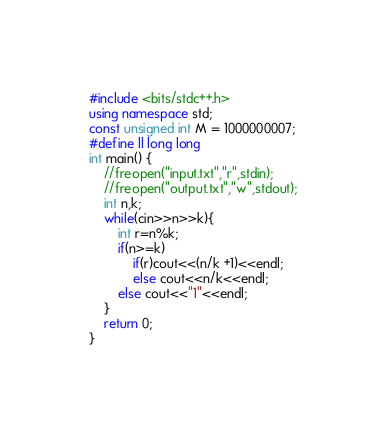<code> <loc_0><loc_0><loc_500><loc_500><_C++_>#include <bits/stdc++.h>
using namespace std;
const unsigned int M = 1000000007;
#define ll long long
int main() {
    //freopen("input.txt","r",stdin);
    //freopen("output.txt","w",stdout);
    int n,k;
    while(cin>>n>>k){
        int r=n%k;
        if(n>=k)
            if(r)cout<<(n/k +1)<<endl;
            else cout<<n/k<<endl;
        else cout<<"1"<<endl;
    }
    return 0;
}
</code> 